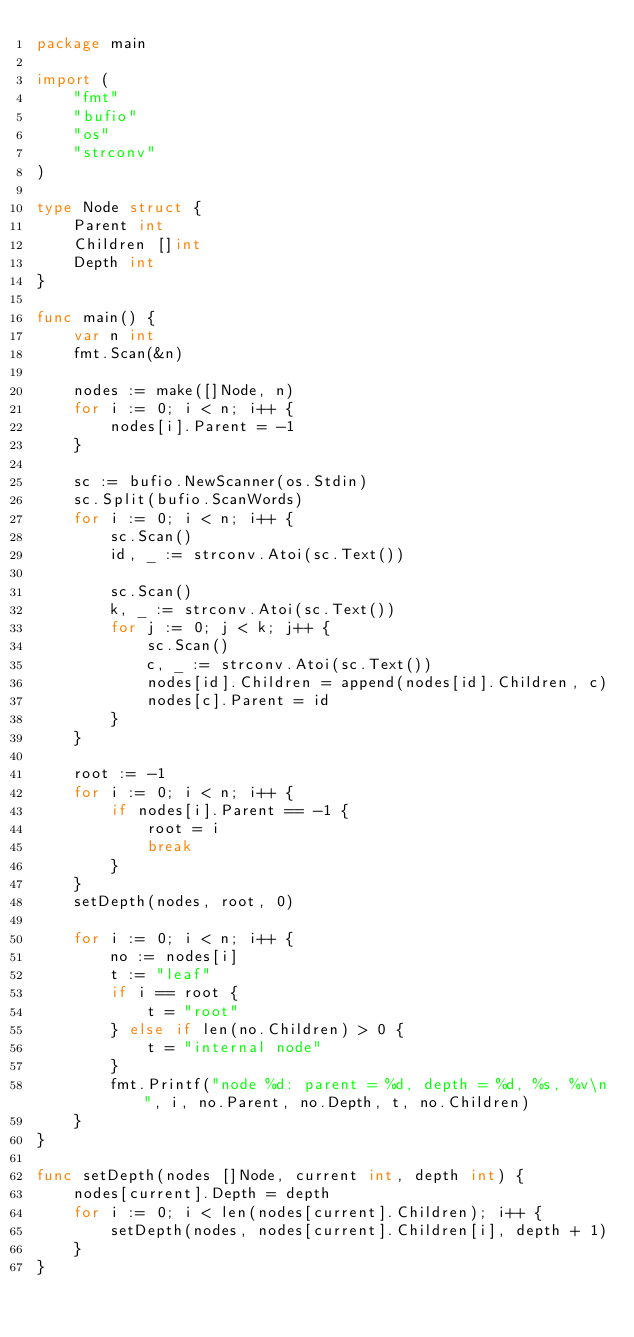Convert code to text. <code><loc_0><loc_0><loc_500><loc_500><_Go_>package main

import (
	"fmt"
	"bufio"
	"os"
	"strconv"
)

type Node struct {
	Parent int
	Children []int
	Depth int
}

func main() {
	var n int
	fmt.Scan(&n)

	nodes := make([]Node, n)
	for i := 0; i < n; i++ {
		nodes[i].Parent = -1
	}

	sc := bufio.NewScanner(os.Stdin)
	sc.Split(bufio.ScanWords)
	for i := 0; i < n; i++ {
		sc.Scan()
		id, _ := strconv.Atoi(sc.Text())
		
		sc.Scan()
		k, _ := strconv.Atoi(sc.Text())
		for j := 0; j < k; j++ {
			sc.Scan()
			c, _ := strconv.Atoi(sc.Text())
			nodes[id].Children = append(nodes[id].Children, c)
			nodes[c].Parent = id
		}
	}

	root := -1
	for i := 0; i < n; i++ {
		if nodes[i].Parent == -1 {
			root = i
			break
		}
	}
	setDepth(nodes, root, 0)

	for i := 0; i < n; i++ {
		no := nodes[i]
		t := "leaf"
		if i == root {
			t = "root"
		} else if len(no.Children) > 0 {
			t = "internal node"
		}
		fmt.Printf("node %d: parent = %d, depth = %d, %s, %v\n", i, no.Parent, no.Depth, t, no.Children)
	}
}

func setDepth(nodes []Node, current int, depth int) {
	nodes[current].Depth = depth
	for i := 0; i < len(nodes[current].Children); i++ {
		setDepth(nodes, nodes[current].Children[i], depth + 1)
	}
}

</code> 